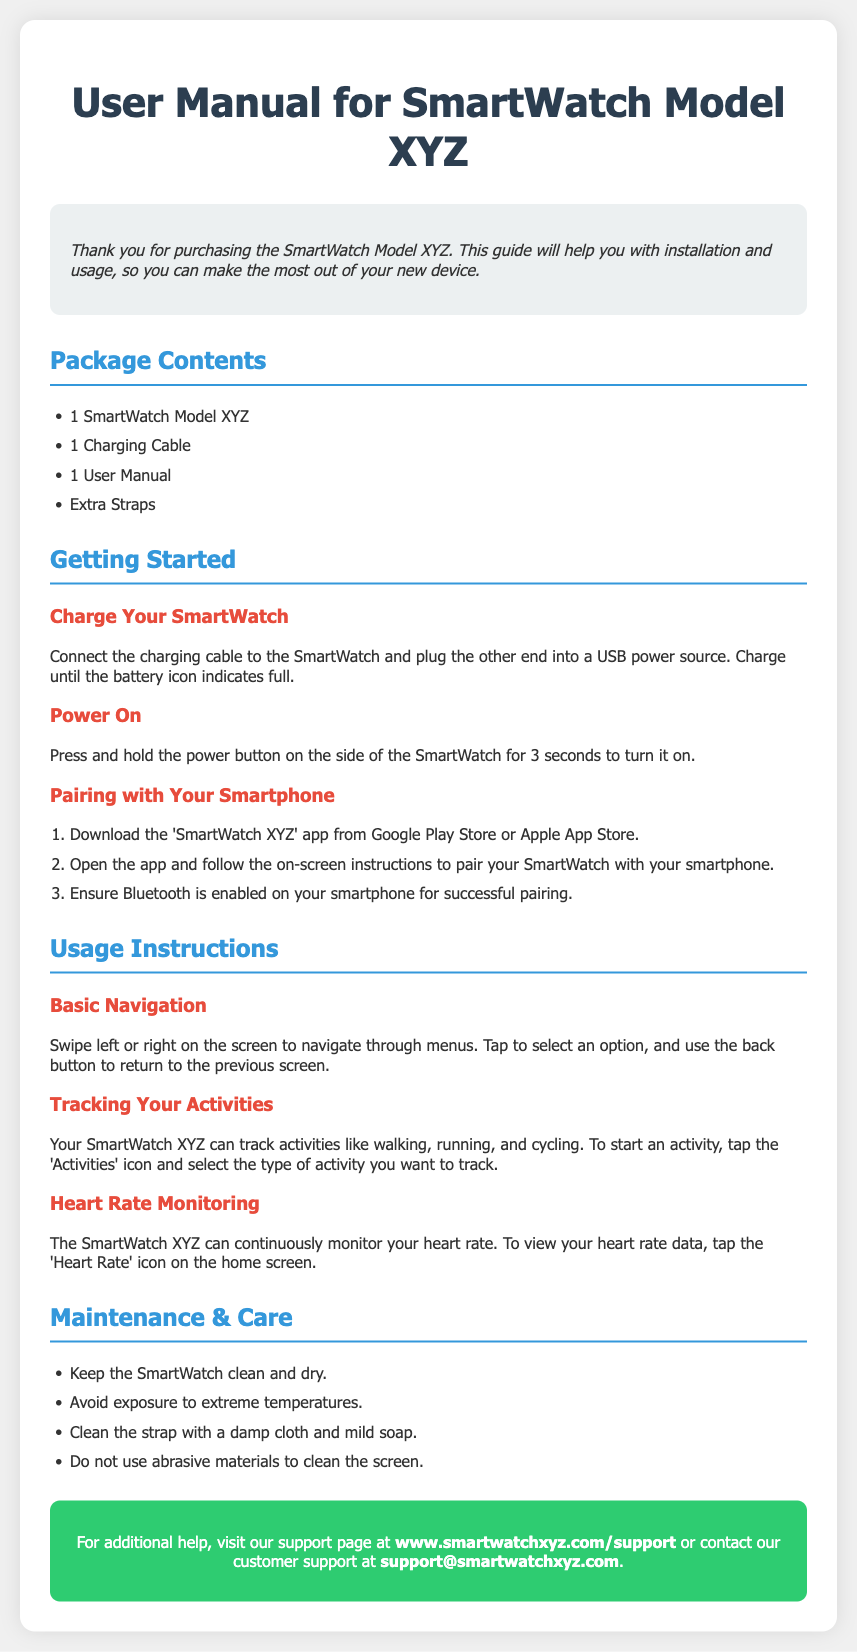What is included in the package? The document lists the contents of the package, which are the SmartWatch, charging cable, user manual, and extra straps.
Answer: SmartWatch Model XYZ, Charging Cable, User Manual, Extra Straps How do I power on the smartwatch? The document specifies that you need to press and hold the power button for 3 seconds to turn on the SmartWatch.
Answer: Press and hold the power button for 3 seconds What should I avoid for maintenance of the smartwatch? The document mentions avoiding exposure to extreme temperatures as part of maintenance.
Answer: Avoid exposure to extreme temperatures What app do I need to download for pairing? The document states that you should download the 'SmartWatch XYZ' app to pair the smartwatch with your phone.
Answer: SmartWatch XYZ How can I track my activities? The document explains that you can track activities by tapping the 'Activities' icon and selecting the type of activity.
Answer: Tap the 'Activities' icon What is the purpose of the support section? The support section provides information on how to get additional help and contact customer support.
Answer: Additional help and customer support How can I clean the smartwatch strap? The document advises cleaning the strap with a damp cloth and mild soap.
Answer: Damp cloth and mild soap What feature does the SmartWatch XYZ have for health tracking? The document mentions that the smartwatch can continuously monitor heart rate.
Answer: Continuous heart rate monitoring 